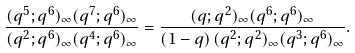<formula> <loc_0><loc_0><loc_500><loc_500>\frac { ( q ^ { 5 } ; q ^ { 6 } ) _ { \infty } ( q ^ { 7 } ; q ^ { 6 } ) _ { \infty } } { ( q ^ { 2 } ; q ^ { 6 } ) _ { \infty } ( q ^ { 4 } ; q ^ { 6 } ) _ { \infty } } = \frac { ( q ; q ^ { 2 } ) _ { \infty } ( q ^ { 6 } ; q ^ { 6 } ) _ { \infty } } { ( 1 - q ) \, ( q ^ { 2 } ; q ^ { 2 } ) _ { \infty } ( q ^ { 3 } ; q ^ { 6 } ) _ { \infty } } .</formula> 